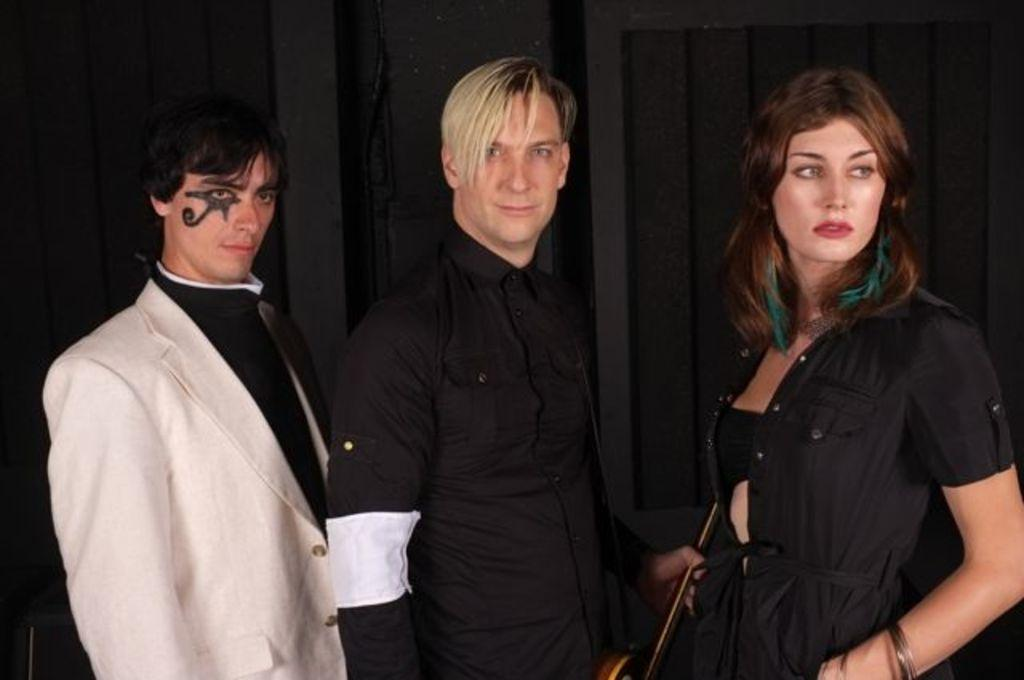How many people are in the image? There are three people in the image. What is one of the people holding? One of the people is holding an object that looks like a guitar. What can be observed about the background of the image? The background of the image is dark. Is there a light bulb visible in the image? There is no light bulb present in the image. What type of hall is depicted in the image? There is no hall depicted in the image; it features three people and a guitar-like object. 